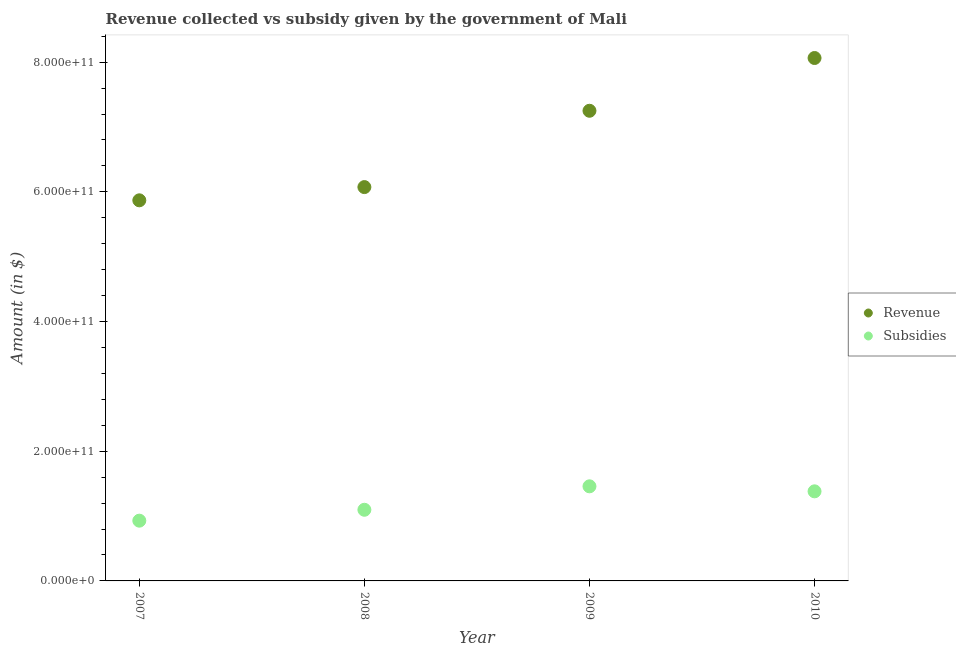How many different coloured dotlines are there?
Your answer should be very brief. 2. Is the number of dotlines equal to the number of legend labels?
Provide a short and direct response. Yes. What is the amount of subsidies given in 2009?
Keep it short and to the point. 1.46e+11. Across all years, what is the maximum amount of revenue collected?
Ensure brevity in your answer.  8.06e+11. Across all years, what is the minimum amount of subsidies given?
Your answer should be compact. 9.29e+1. In which year was the amount of revenue collected maximum?
Your response must be concise. 2010. What is the total amount of revenue collected in the graph?
Make the answer very short. 2.73e+12. What is the difference between the amount of revenue collected in 2008 and that in 2009?
Your answer should be very brief. -1.18e+11. What is the difference between the amount of subsidies given in 2007 and the amount of revenue collected in 2010?
Provide a succinct answer. -7.13e+11. What is the average amount of subsidies given per year?
Your answer should be very brief. 1.22e+11. In the year 2009, what is the difference between the amount of revenue collected and amount of subsidies given?
Give a very brief answer. 5.79e+11. In how many years, is the amount of revenue collected greater than 640000000000 $?
Your answer should be very brief. 2. What is the ratio of the amount of subsidies given in 2008 to that in 2010?
Make the answer very short. 0.79. Is the amount of subsidies given in 2007 less than that in 2008?
Keep it short and to the point. Yes. Is the difference between the amount of revenue collected in 2007 and 2008 greater than the difference between the amount of subsidies given in 2007 and 2008?
Your answer should be very brief. No. What is the difference between the highest and the second highest amount of subsidies given?
Provide a short and direct response. 7.72e+09. What is the difference between the highest and the lowest amount of subsidies given?
Keep it short and to the point. 5.30e+1. Is the sum of the amount of revenue collected in 2008 and 2009 greater than the maximum amount of subsidies given across all years?
Keep it short and to the point. Yes. Does the amount of subsidies given monotonically increase over the years?
Keep it short and to the point. No. How many years are there in the graph?
Your answer should be compact. 4. What is the difference between two consecutive major ticks on the Y-axis?
Your response must be concise. 2.00e+11. Where does the legend appear in the graph?
Offer a terse response. Center right. What is the title of the graph?
Your answer should be very brief. Revenue collected vs subsidy given by the government of Mali. What is the label or title of the X-axis?
Your answer should be compact. Year. What is the label or title of the Y-axis?
Ensure brevity in your answer.  Amount (in $). What is the Amount (in $) in Revenue in 2007?
Keep it short and to the point. 5.87e+11. What is the Amount (in $) in Subsidies in 2007?
Provide a succinct answer. 9.29e+1. What is the Amount (in $) of Revenue in 2008?
Provide a succinct answer. 6.07e+11. What is the Amount (in $) in Subsidies in 2008?
Provide a succinct answer. 1.10e+11. What is the Amount (in $) of Revenue in 2009?
Ensure brevity in your answer.  7.25e+11. What is the Amount (in $) in Subsidies in 2009?
Your answer should be compact. 1.46e+11. What is the Amount (in $) of Revenue in 2010?
Keep it short and to the point. 8.06e+11. What is the Amount (in $) in Subsidies in 2010?
Provide a succinct answer. 1.38e+11. Across all years, what is the maximum Amount (in $) in Revenue?
Give a very brief answer. 8.06e+11. Across all years, what is the maximum Amount (in $) in Subsidies?
Give a very brief answer. 1.46e+11. Across all years, what is the minimum Amount (in $) in Revenue?
Provide a short and direct response. 5.87e+11. Across all years, what is the minimum Amount (in $) in Subsidies?
Your answer should be compact. 9.29e+1. What is the total Amount (in $) in Revenue in the graph?
Your answer should be compact. 2.73e+12. What is the total Amount (in $) of Subsidies in the graph?
Keep it short and to the point. 4.87e+11. What is the difference between the Amount (in $) of Revenue in 2007 and that in 2008?
Your response must be concise. -2.04e+1. What is the difference between the Amount (in $) of Subsidies in 2007 and that in 2008?
Your answer should be compact. -1.68e+1. What is the difference between the Amount (in $) of Revenue in 2007 and that in 2009?
Your answer should be compact. -1.38e+11. What is the difference between the Amount (in $) in Subsidies in 2007 and that in 2009?
Offer a terse response. -5.30e+1. What is the difference between the Amount (in $) in Revenue in 2007 and that in 2010?
Make the answer very short. -2.19e+11. What is the difference between the Amount (in $) in Subsidies in 2007 and that in 2010?
Make the answer very short. -4.52e+1. What is the difference between the Amount (in $) of Revenue in 2008 and that in 2009?
Your answer should be compact. -1.18e+11. What is the difference between the Amount (in $) of Subsidies in 2008 and that in 2009?
Your answer should be compact. -3.62e+1. What is the difference between the Amount (in $) in Revenue in 2008 and that in 2010?
Provide a short and direct response. -1.99e+11. What is the difference between the Amount (in $) in Subsidies in 2008 and that in 2010?
Keep it short and to the point. -2.84e+1. What is the difference between the Amount (in $) of Revenue in 2009 and that in 2010?
Offer a terse response. -8.14e+1. What is the difference between the Amount (in $) in Subsidies in 2009 and that in 2010?
Offer a very short reply. 7.72e+09. What is the difference between the Amount (in $) of Revenue in 2007 and the Amount (in $) of Subsidies in 2008?
Your answer should be compact. 4.77e+11. What is the difference between the Amount (in $) in Revenue in 2007 and the Amount (in $) in Subsidies in 2009?
Give a very brief answer. 4.41e+11. What is the difference between the Amount (in $) in Revenue in 2007 and the Amount (in $) in Subsidies in 2010?
Give a very brief answer. 4.49e+11. What is the difference between the Amount (in $) in Revenue in 2008 and the Amount (in $) in Subsidies in 2009?
Provide a short and direct response. 4.61e+11. What is the difference between the Amount (in $) of Revenue in 2008 and the Amount (in $) of Subsidies in 2010?
Provide a short and direct response. 4.69e+11. What is the difference between the Amount (in $) in Revenue in 2009 and the Amount (in $) in Subsidies in 2010?
Make the answer very short. 5.87e+11. What is the average Amount (in $) of Revenue per year?
Ensure brevity in your answer.  6.81e+11. What is the average Amount (in $) of Subsidies per year?
Ensure brevity in your answer.  1.22e+11. In the year 2007, what is the difference between the Amount (in $) of Revenue and Amount (in $) of Subsidies?
Keep it short and to the point. 4.94e+11. In the year 2008, what is the difference between the Amount (in $) of Revenue and Amount (in $) of Subsidies?
Your response must be concise. 4.98e+11. In the year 2009, what is the difference between the Amount (in $) in Revenue and Amount (in $) in Subsidies?
Your answer should be compact. 5.79e+11. In the year 2010, what is the difference between the Amount (in $) of Revenue and Amount (in $) of Subsidies?
Your answer should be very brief. 6.68e+11. What is the ratio of the Amount (in $) in Revenue in 2007 to that in 2008?
Keep it short and to the point. 0.97. What is the ratio of the Amount (in $) of Subsidies in 2007 to that in 2008?
Your response must be concise. 0.85. What is the ratio of the Amount (in $) in Revenue in 2007 to that in 2009?
Offer a very short reply. 0.81. What is the ratio of the Amount (in $) of Subsidies in 2007 to that in 2009?
Keep it short and to the point. 0.64. What is the ratio of the Amount (in $) of Revenue in 2007 to that in 2010?
Your answer should be very brief. 0.73. What is the ratio of the Amount (in $) in Subsidies in 2007 to that in 2010?
Offer a very short reply. 0.67. What is the ratio of the Amount (in $) in Revenue in 2008 to that in 2009?
Offer a very short reply. 0.84. What is the ratio of the Amount (in $) in Subsidies in 2008 to that in 2009?
Offer a very short reply. 0.75. What is the ratio of the Amount (in $) of Revenue in 2008 to that in 2010?
Keep it short and to the point. 0.75. What is the ratio of the Amount (in $) in Subsidies in 2008 to that in 2010?
Offer a terse response. 0.79. What is the ratio of the Amount (in $) of Revenue in 2009 to that in 2010?
Keep it short and to the point. 0.9. What is the ratio of the Amount (in $) in Subsidies in 2009 to that in 2010?
Your answer should be compact. 1.06. What is the difference between the highest and the second highest Amount (in $) of Revenue?
Ensure brevity in your answer.  8.14e+1. What is the difference between the highest and the second highest Amount (in $) of Subsidies?
Your response must be concise. 7.72e+09. What is the difference between the highest and the lowest Amount (in $) of Revenue?
Your answer should be compact. 2.19e+11. What is the difference between the highest and the lowest Amount (in $) in Subsidies?
Offer a terse response. 5.30e+1. 